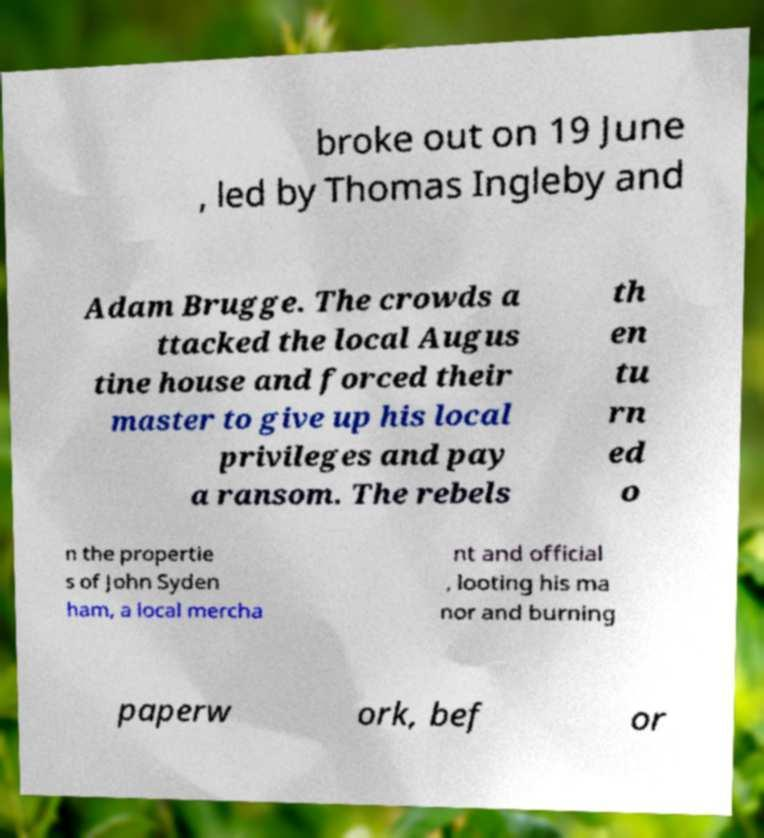Could you extract and type out the text from this image? broke out on 19 June , led by Thomas Ingleby and Adam Brugge. The crowds a ttacked the local Augus tine house and forced their master to give up his local privileges and pay a ransom. The rebels th en tu rn ed o n the propertie s of John Syden ham, a local mercha nt and official , looting his ma nor and burning paperw ork, bef or 